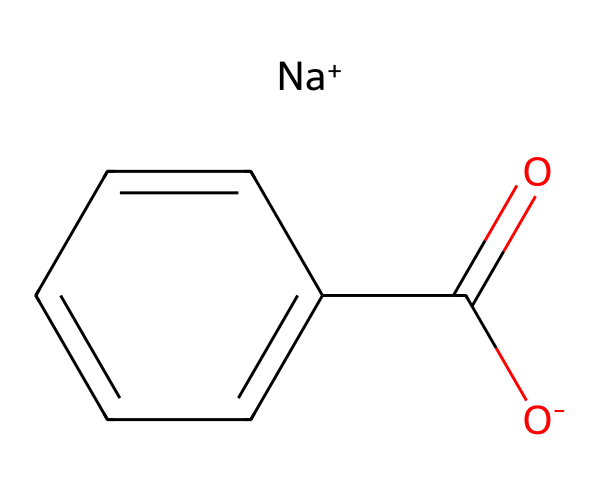What is the common name of this compound? Sodium benzoate is the IUPAC name derived from its chemical structure, which includes a sodium ion and benzoate group.
Answer: sodium benzoate How many carbon atoms are present in sodium benzoate? By examining the structure, there are seven carbon atoms in total: six from the benzene ring and one from the carboxylate group.
Answer: 7 What type of ion is associated with the carboxylate group? The chemical shows an O- (negative oxygen) linked to a carbonyl C(=O), which confirms that it is a carboxylate ion.
Answer: carboxylate What is the role of sodium benzoate in food preservation? Sodium benzoate functions primarily as a preservative by inhibiting the growth of bacteria, yeast, and molds due to its pH-dependent antimicrobial properties.
Answer: preservative How many oxygen atoms are present in sodium benzoate? The chemical has two distinct oxygen atoms: one in the carboxylate ion (O-) and one in the carbonyl group (C=O).
Answer: 2 From which acid is sodium benzoate derived? Sodium benzoate is the sodium salt of benzoic acid, indicating that it is derived from this acid.
Answer: benzoic acid What is the charge on the sodium ion in this compound? The sodium ion is indicated by [Na+], which specifies that it carries a positive charge.
Answer: positive 